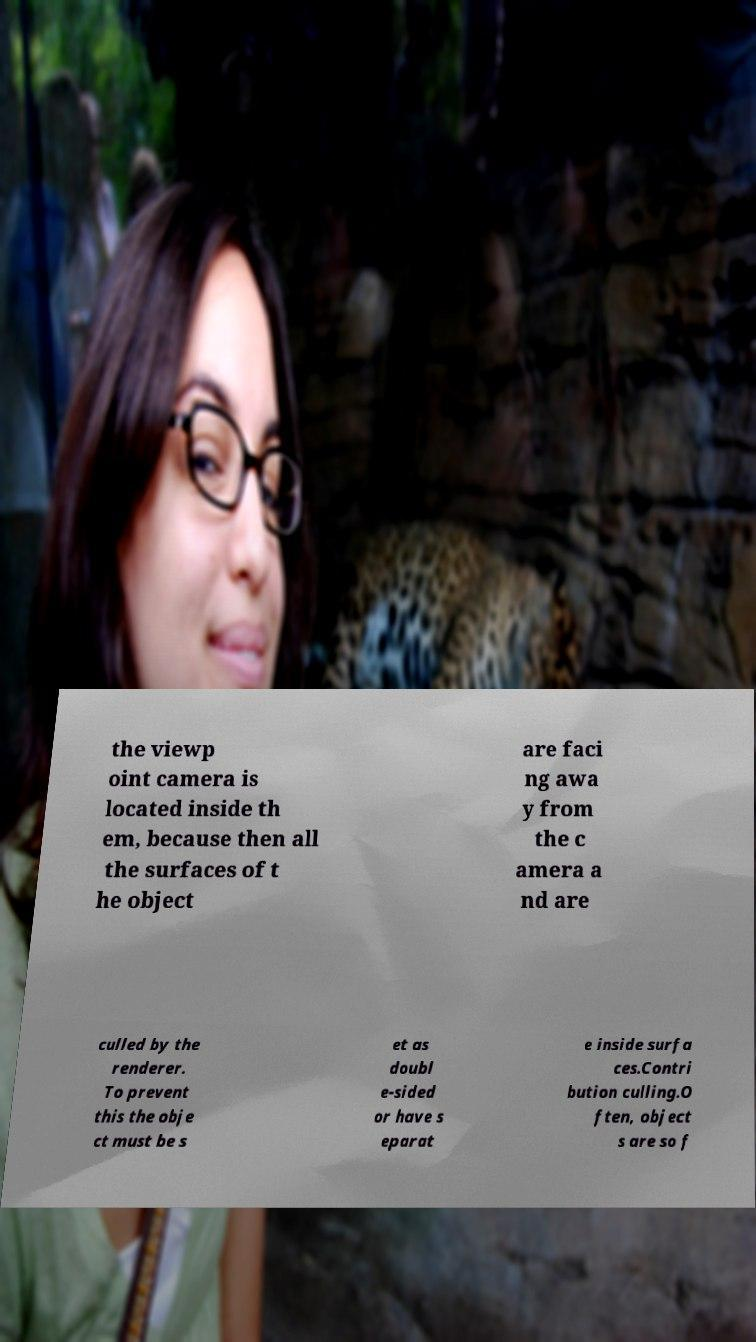Please read and relay the text visible in this image. What does it say? the viewp oint camera is located inside th em, because then all the surfaces of t he object are faci ng awa y from the c amera a nd are culled by the renderer. To prevent this the obje ct must be s et as doubl e-sided or have s eparat e inside surfa ces.Contri bution culling.O ften, object s are so f 